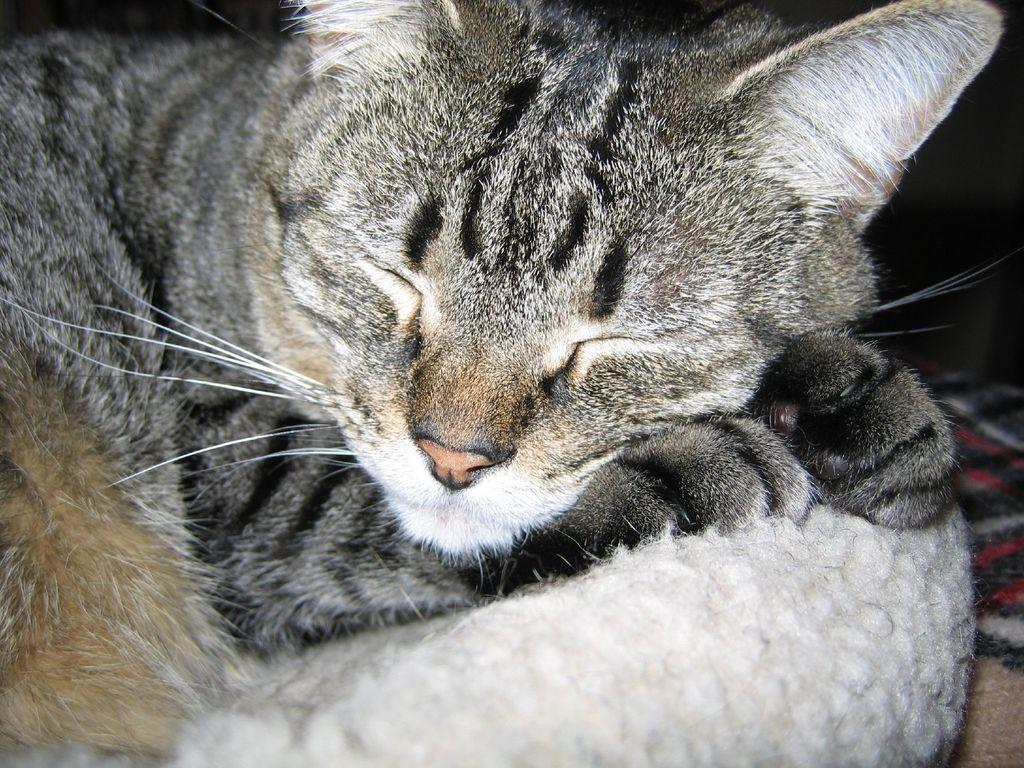What animal is present in the image? There is a cat in the image. What is the cat doing in the image? The cat is sleeping. What is the cat resting on in the image? The cat is on a cloth. What type of breath can be seen coming from the cat's dad in the image? There is no cat's dad present in the image, and therefore no breath can be observed. 